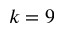Convert formula to latex. <formula><loc_0><loc_0><loc_500><loc_500>k = 9</formula> 